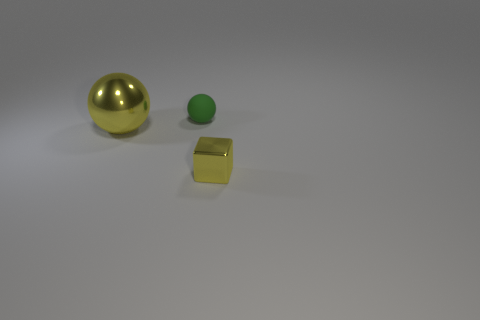What is the shape of the metallic object that is the same color as the small metal cube?
Make the answer very short. Sphere. Is there a small blue object made of the same material as the tiny sphere?
Your answer should be compact. No. The yellow metal ball is what size?
Ensure brevity in your answer.  Large. What number of blue things are either large matte cylinders or shiny spheres?
Provide a short and direct response. 0. How many yellow objects have the same shape as the green thing?
Offer a very short reply. 1. What number of other green spheres are the same size as the green matte sphere?
Your answer should be compact. 0. What material is the large yellow thing that is the same shape as the small green rubber object?
Offer a terse response. Metal. What is the color of the small object in front of the green thing?
Your response must be concise. Yellow. Are there more small rubber balls on the right side of the big metal ball than small gray metallic spheres?
Give a very brief answer. Yes. The cube has what color?
Your answer should be very brief. Yellow. 